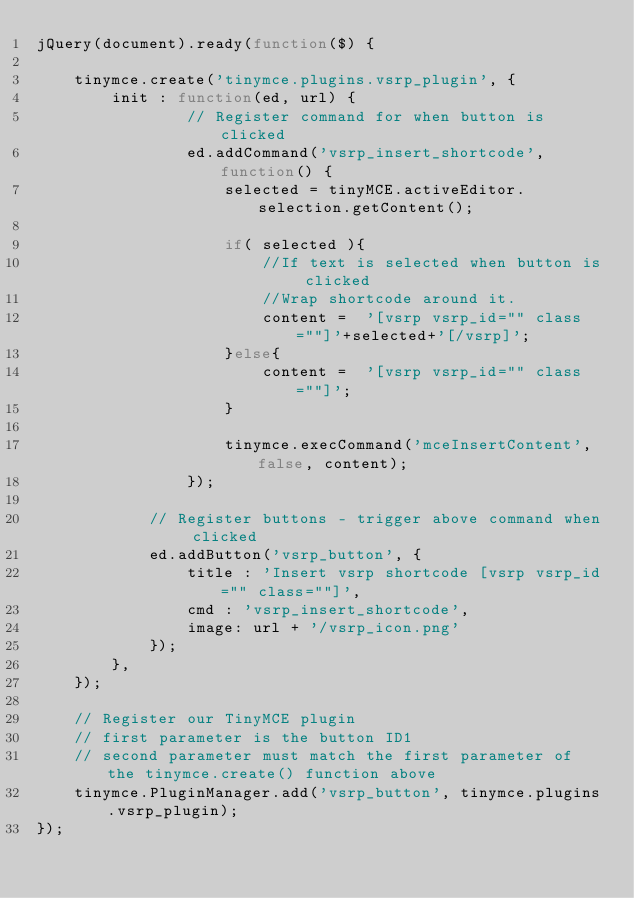Convert code to text. <code><loc_0><loc_0><loc_500><loc_500><_JavaScript_>jQuery(document).ready(function($) {

    tinymce.create('tinymce.plugins.vsrp_plugin', {
        init : function(ed, url) {
                // Register command for when button is clicked
                ed.addCommand('vsrp_insert_shortcode', function() {
                    selected = tinyMCE.activeEditor.selection.getContent();

                    if( selected ){
                        //If text is selected when button is clicked
                        //Wrap shortcode around it.
                        content =  '[vsrp vsrp_id="" class=""]'+selected+'[/vsrp]';
                    }else{
                        content =  '[vsrp vsrp_id="" class=""]';
                    }

                    tinymce.execCommand('mceInsertContent', false, content);
                });

            // Register buttons - trigger above command when clicked
            ed.addButton('vsrp_button', {
                title : 'Insert vsrp shortcode [vsrp vsrp_id="" class=""]',
                cmd : 'vsrp_insert_shortcode',
                image: url + '/vsrp_icon.png'
            });
        },   
    });

    // Register our TinyMCE plugin
    // first parameter is the button ID1
    // second parameter must match the first parameter of the tinymce.create() function above
    tinymce.PluginManager.add('vsrp_button', tinymce.plugins.vsrp_plugin);
});</code> 